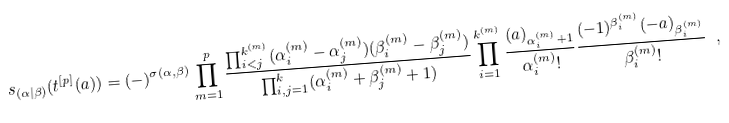Convert formula to latex. <formula><loc_0><loc_0><loc_500><loc_500>s _ { ( \alpha | \beta ) } ( { t } ^ { [ p ] } ( a ) ) = ( - ) ^ { \sigma ( \alpha , \beta ) } \prod ^ { p } _ { m = 1 } \frac { \prod ^ { k ^ { ( m ) } } _ { i < j } ( \alpha _ { i } ^ { ( m ) } - \alpha _ { j } ^ { ( m ) } ) ( \beta _ { i } ^ { ( m ) } - \beta _ { j } ^ { ( m ) } ) } { \prod _ { i , j = 1 } ^ { k } ( \alpha _ { i } ^ { ( m ) } + \beta _ { j } ^ { ( m ) } + 1 ) } \prod _ { i = 1 } ^ { k ^ { ( m ) } } \frac { ( a ) _ { \alpha _ { i } ^ { ( m ) } + 1 } } { \alpha _ { i } ^ { ( m ) } ! } \frac { ( - 1 ) ^ { \beta _ { i } ^ { ( m ) } } ( - a ) _ { \beta _ { i } ^ { ( m ) } } } { \beta _ { i } ^ { ( m ) } ! } \ ,</formula> 